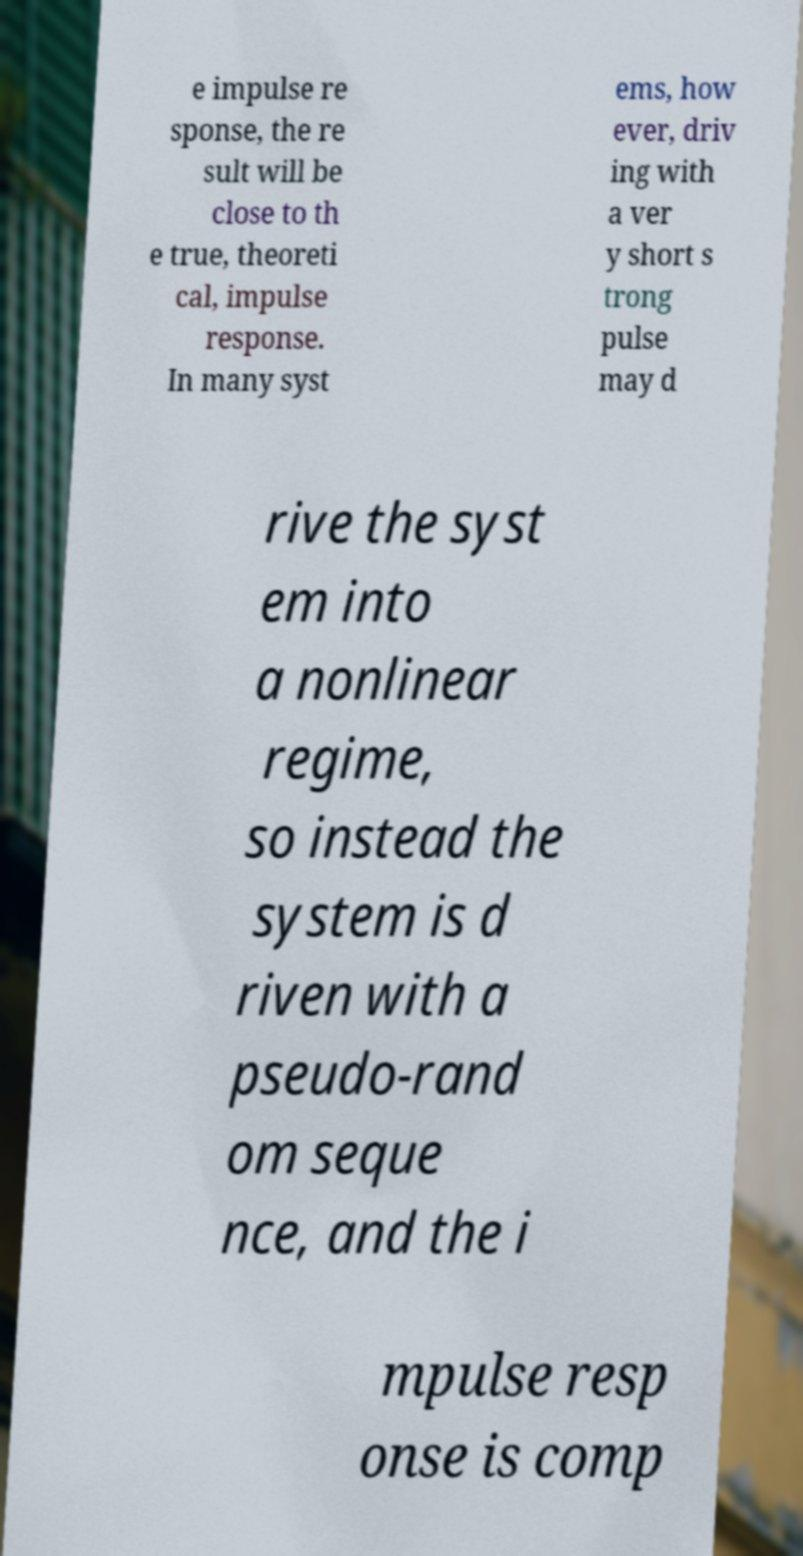I need the written content from this picture converted into text. Can you do that? e impulse re sponse, the re sult will be close to th e true, theoreti cal, impulse response. In many syst ems, how ever, driv ing with a ver y short s trong pulse may d rive the syst em into a nonlinear regime, so instead the system is d riven with a pseudo-rand om seque nce, and the i mpulse resp onse is comp 